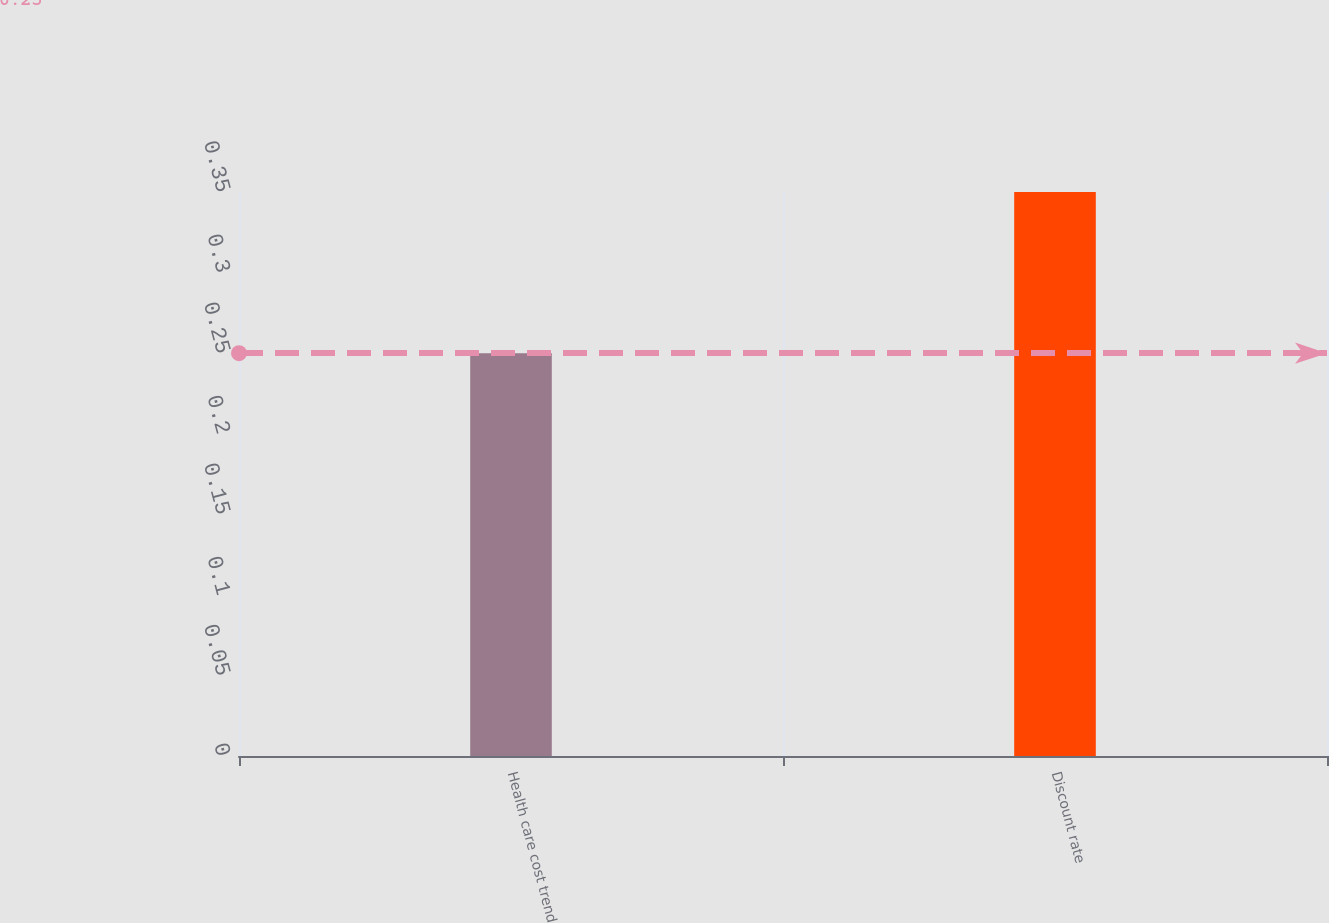Convert chart. <chart><loc_0><loc_0><loc_500><loc_500><bar_chart><fcel>Health care cost trend<fcel>Discount rate<nl><fcel>0.25<fcel>0.35<nl></chart> 